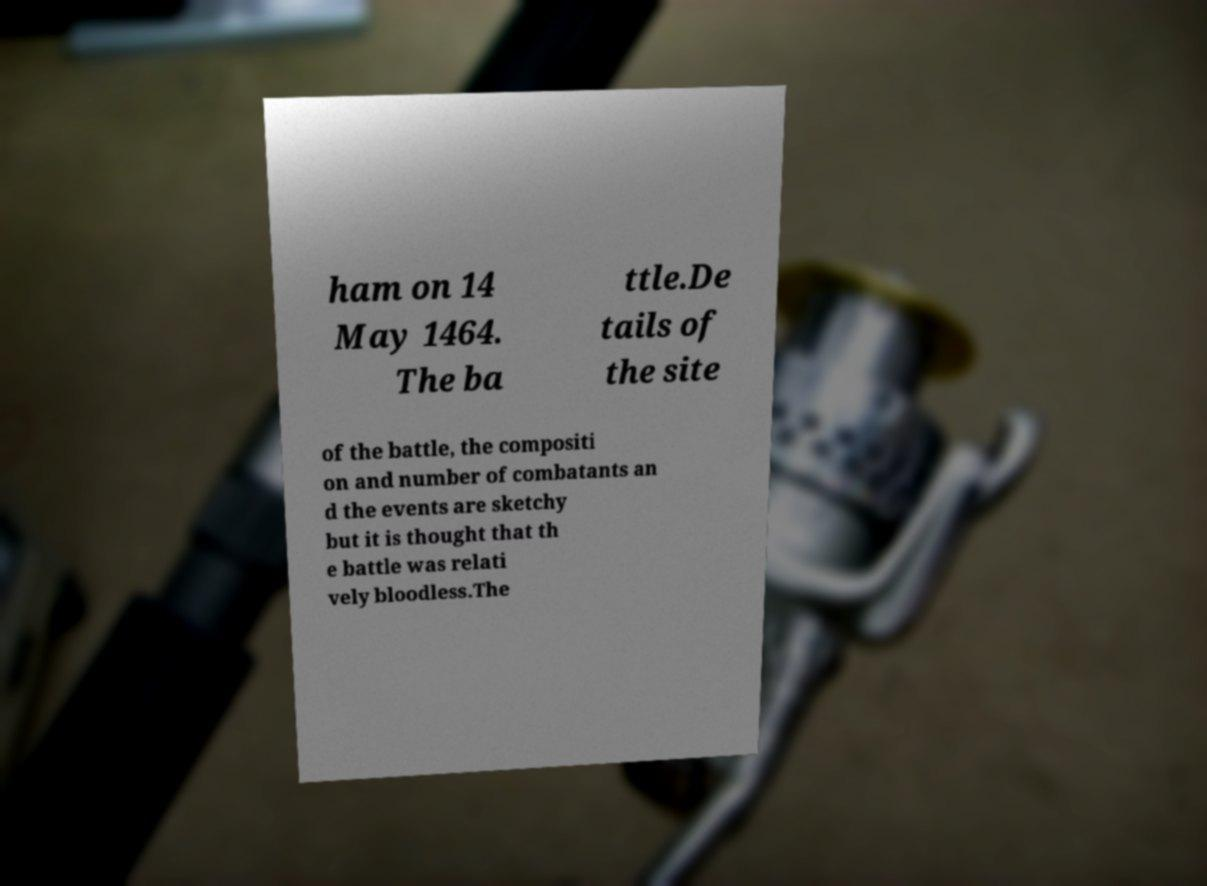Can you read and provide the text displayed in the image?This photo seems to have some interesting text. Can you extract and type it out for me? ham on 14 May 1464. The ba ttle.De tails of the site of the battle, the compositi on and number of combatants an d the events are sketchy but it is thought that th e battle was relati vely bloodless.The 